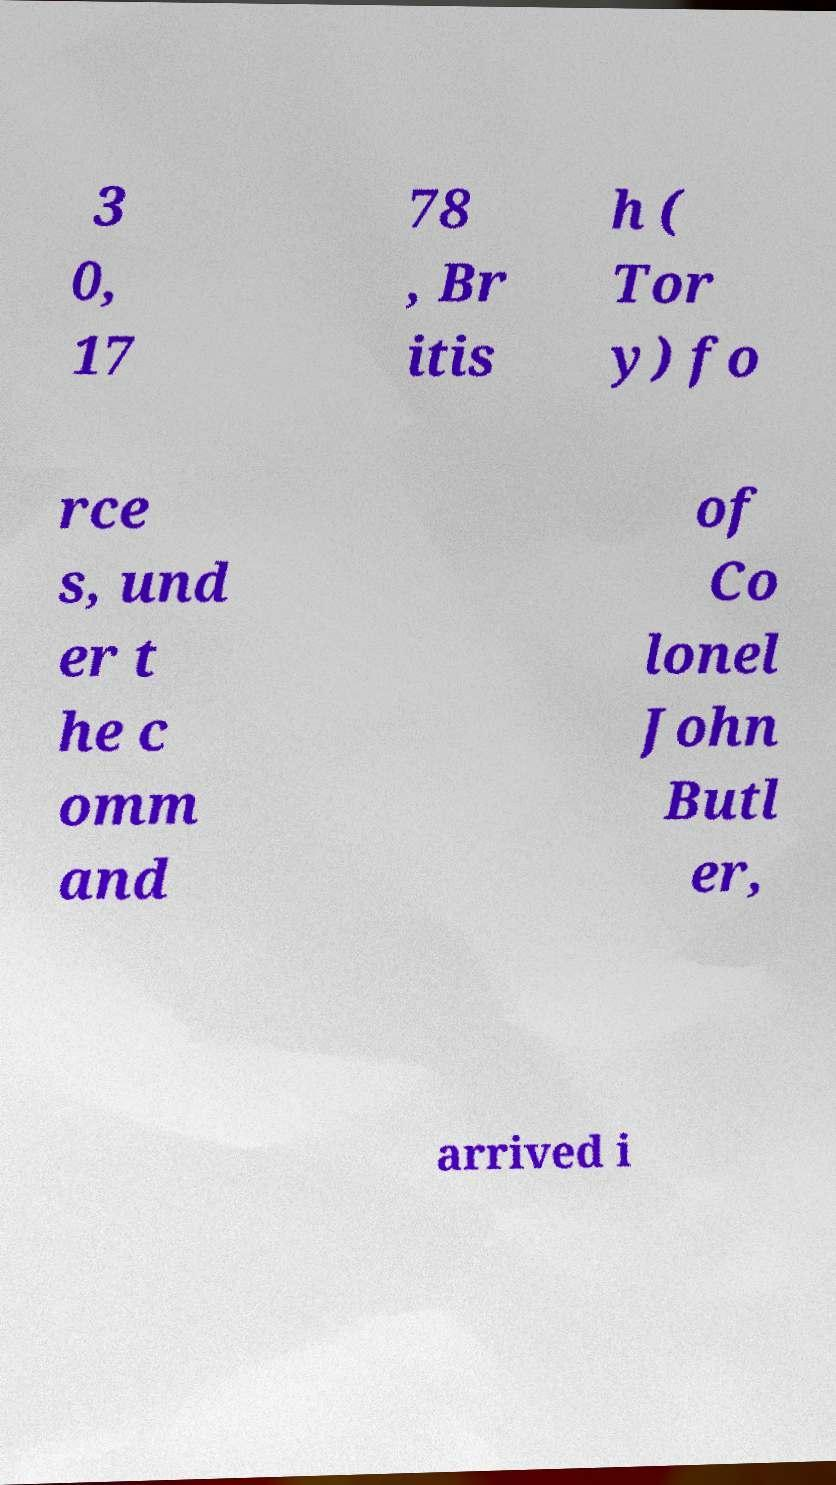What messages or text are displayed in this image? I need them in a readable, typed format. 3 0, 17 78 , Br itis h ( Tor y) fo rce s, und er t he c omm and of Co lonel John Butl er, arrived i 